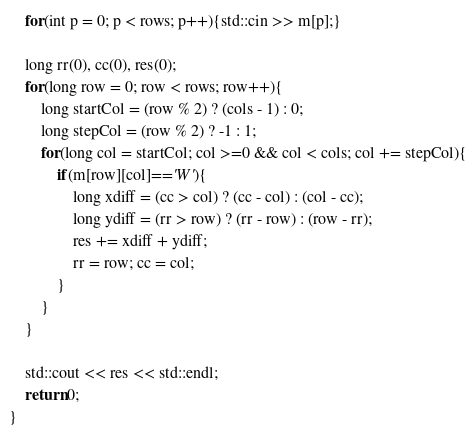<code> <loc_0><loc_0><loc_500><loc_500><_C++_>    for(int p = 0; p < rows; p++){std::cin >> m[p];}

    long rr(0), cc(0), res(0);
    for(long row = 0; row < rows; row++){
        long startCol = (row % 2) ? (cols - 1) : 0;
        long stepCol = (row % 2) ? -1 : 1;
        for(long col = startCol; col >=0 && col < cols; col += stepCol){
            if(m[row][col]=='W'){
                long xdiff = (cc > col) ? (cc - col) : (col - cc);
                long ydiff = (rr > row) ? (rr - row) : (row - rr);
                res += xdiff + ydiff;
                rr = row; cc = col;
            }
        }
    }

    std::cout << res << std::endl;
    return 0;
}
</code> 